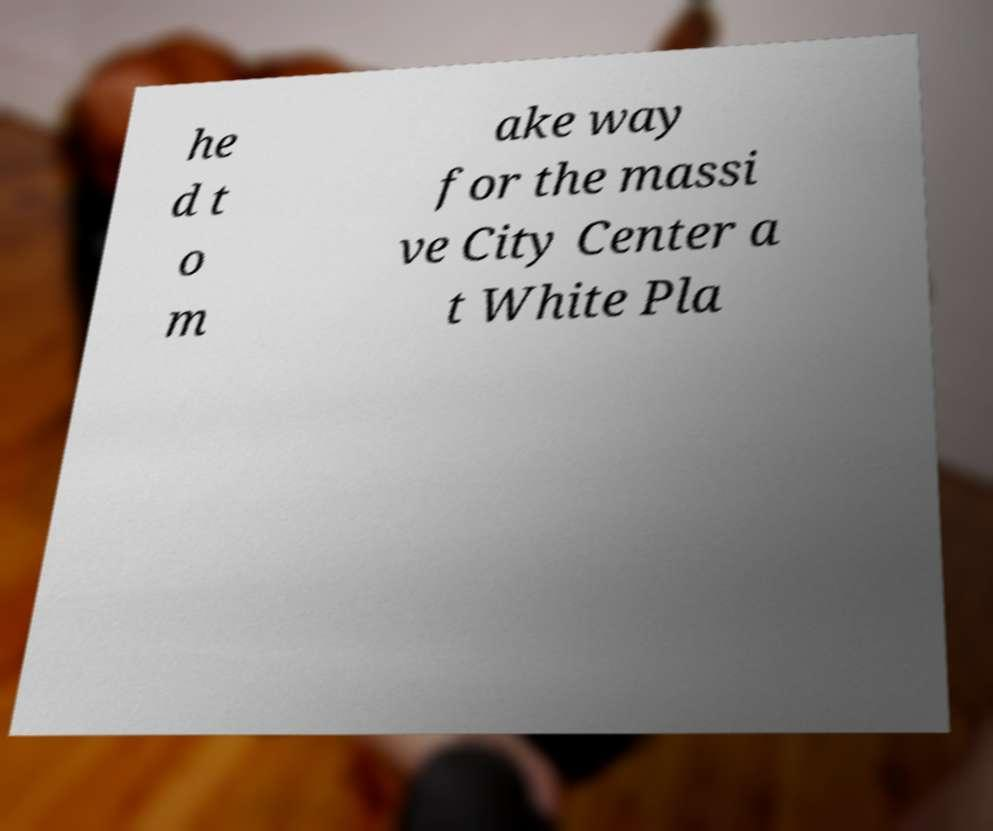I need the written content from this picture converted into text. Can you do that? he d t o m ake way for the massi ve City Center a t White Pla 